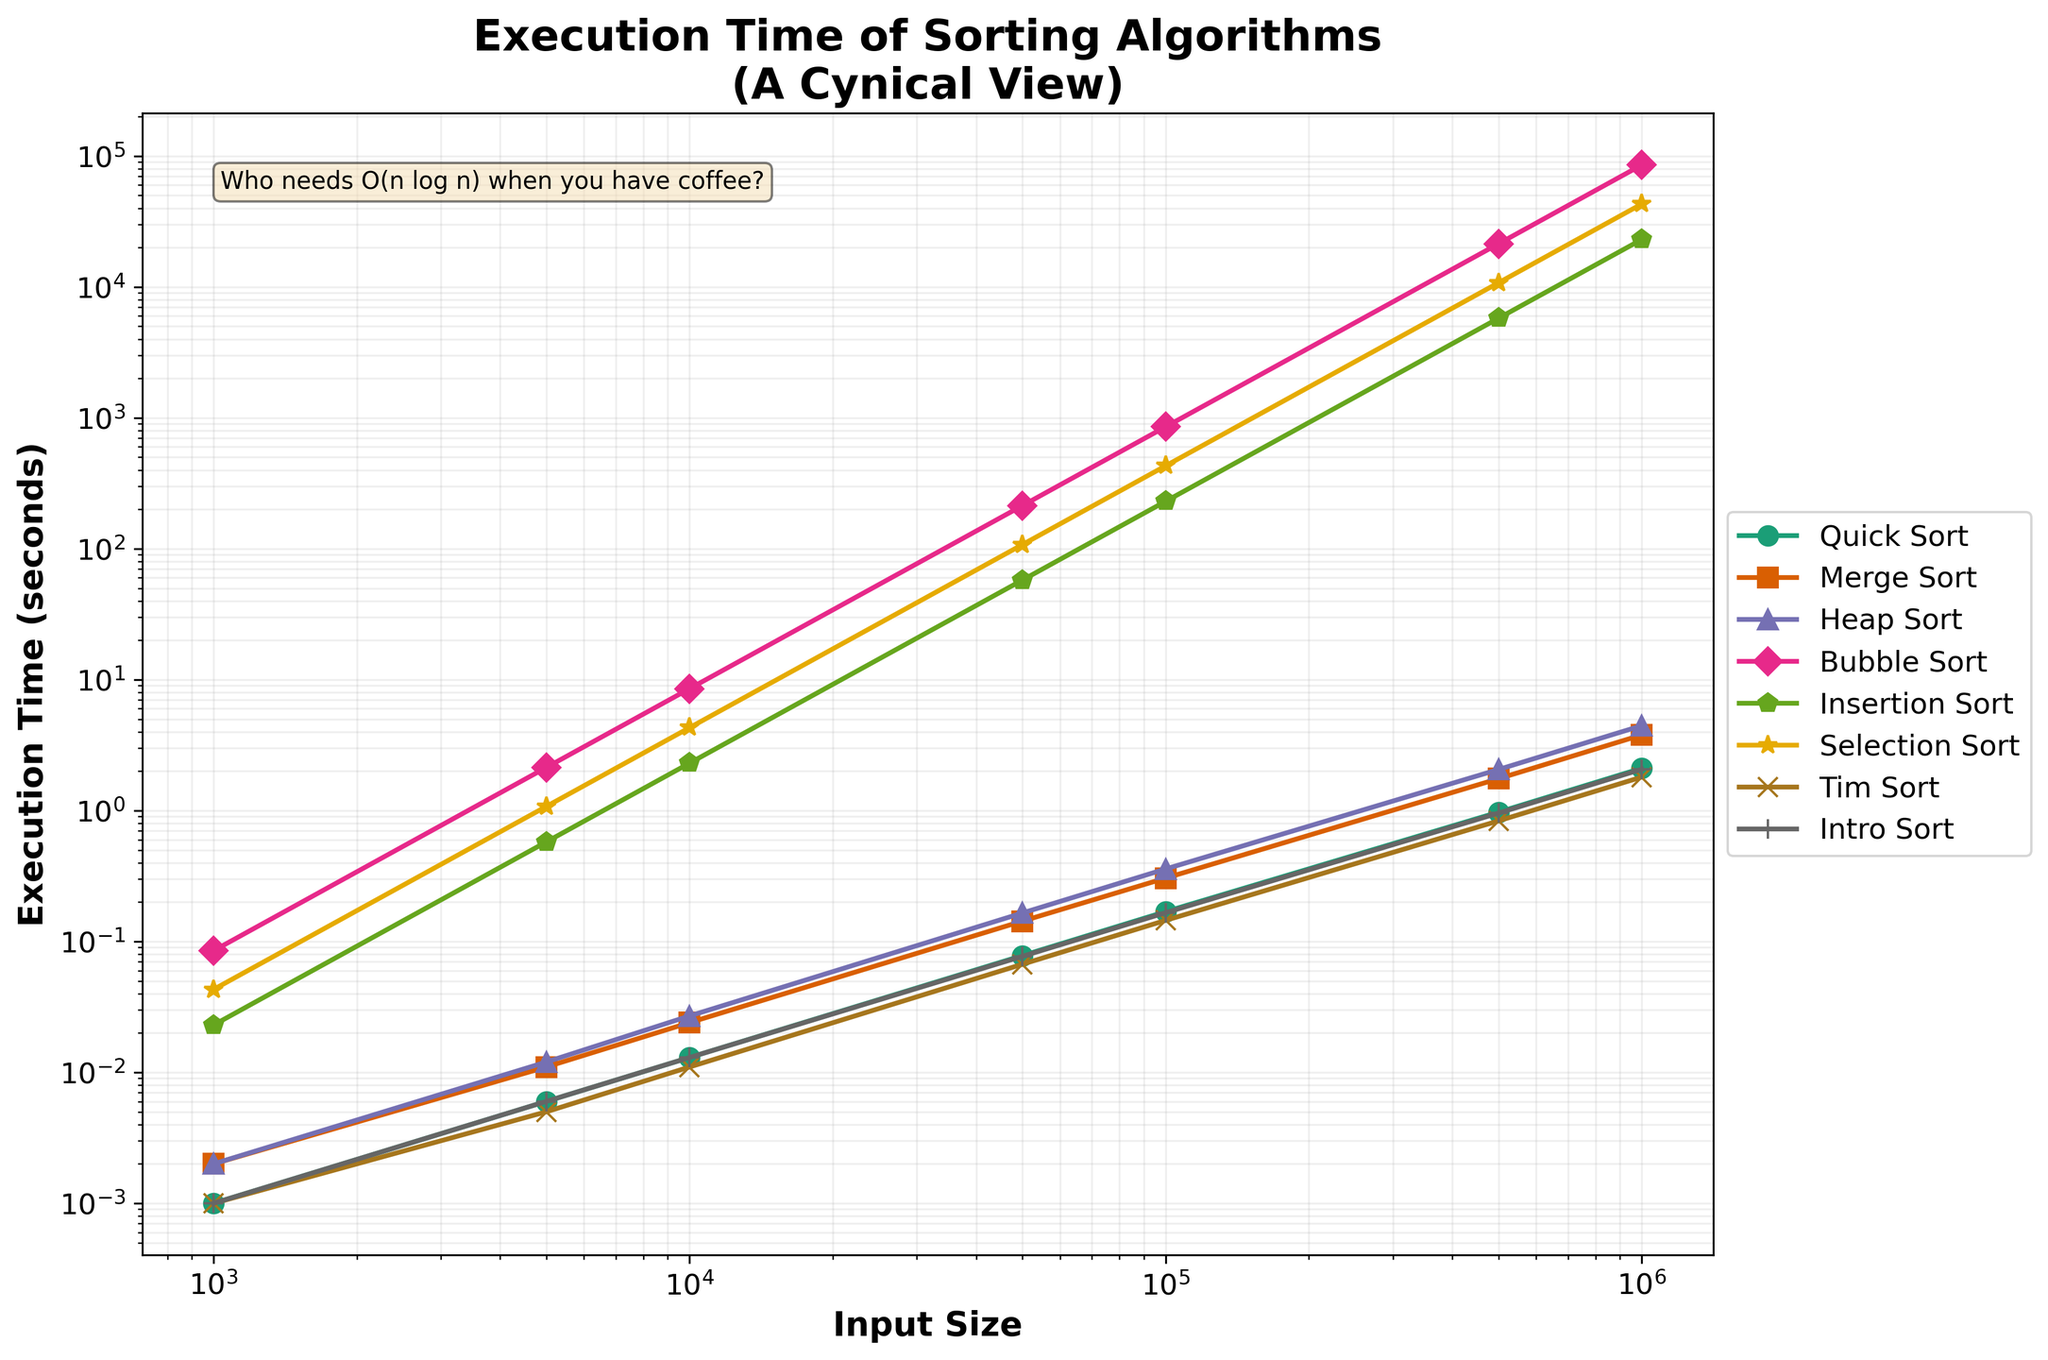Which sorting algorithm has the lowest execution time across all input sizes? By looking at the plot, Quick Sort consistently has the lowest execution time across all given input sizes from 1,000 to 1,000,000.
Answer: Quick Sort Which sorting algorithm has the highest execution time for an input size of 500,000? The plot shows that Bubble Sort has the highest execution time for an input size of 500,000, significantly higher than any other sorting algorithm.
Answer: Bubble Sort How much faster is Quick Sort compared to Bubble Sort at an input size of 100,000? To find how much faster Quick Sort is, subtract Quick Sort's execution time from Bubble Sort's execution time for 100,000 elements. Bubble Sort takes 854.700 seconds and Quick Sort takes 0.169 seconds. The difference is 854.700 - 0.169 = 854.531 seconds.
Answer: 854.531 seconds Which sorting algorithms exhibit similar performance characteristics to Quick Sort? The plot indicates that Tim Sort and Intro Sort have performance characteristics very close to Quick Sort, with overlapping lines on the log-log scale chart.
Answer: Tim Sort and Intro Sort What is the approximate execution time difference between Merge Sort and Heap Sort at an input size of 10,000? At an input size of 10,000 elements, the execution times for Merge Sort and Heap Sort are about 0.024 and 0.027 seconds, respectively. The difference is 0.027 - 0.024 = 0.003 seconds.
Answer: 0.003 seconds Between Insertion Sort and Selection Sort, which one has a higher execution time at every input size? The plot shows that Selection Sort consistently has a higher execution time compared to Insertion Sort for all input sizes listed from 1,000 to 1,000,000.
Answer: Selection Sort What appears to be the biggest issue with using Bubble Sort for large input sizes? Based on the chart, as input size increases, Bubble Sort’s execution time grows extremely rapidly, making it impractical for large input sizes due to its poor scaling and inefficiency.
Answer: Poor scaling and inefficiency How does Tim Sort’s execution time scale compared to Merge Sort for input sizes beyond 10,000? The plot shows that beyond 10,000 elements, Tim Sort consistently takes less time to execute than Merge Sort, indicating better scalability for larger input sizes.
Answer: Better scalability What is the color and shape used for Quick Sort in the plot? The quick sort line is indicated using a specific color and marker. By visually inspecting the plot, we see that Quick Sort is represented by an orange line and circular markers.
Answer: Orange and circular markers As input size increases, what happens to the execution time difference between Heap Sort and Bubble Sort? The plot demonstrates that as input size increases, the execution time difference between Heap Sort and Bubble Sort becomes exponentially larger, with Bubble Sort's execution time dramatically outpacing Heap Sort as input size grows.
Answer: Exponentially larger 